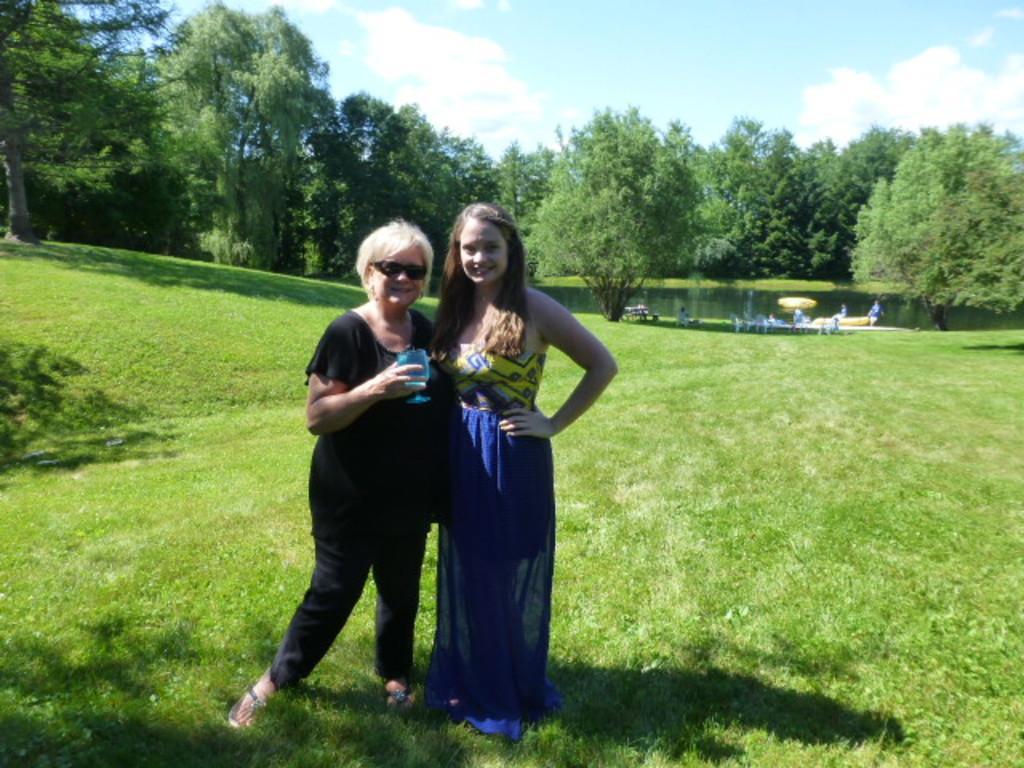Describe this image in one or two sentences. In this picture we can see few people, two women are standing on the grass, in the background we can see few chairs, trees and water. 